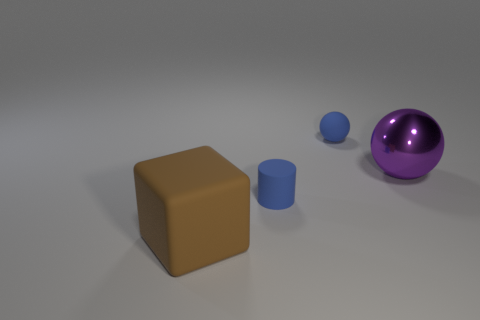Is the color of the tiny ball the same as the small thing that is in front of the metallic ball?
Make the answer very short. Yes. There is a blue matte thing that is behind the purple shiny thing; is it the same shape as the big purple thing?
Keep it short and to the point. Yes. How many large things are either cyan blocks or matte cylinders?
Provide a succinct answer. 0. Is the material of the blue cylinder the same as the small blue ball?
Provide a succinct answer. Yes. Are there any big rubber objects of the same color as the large metal thing?
Ensure brevity in your answer.  No. There is a brown cube that is the same material as the cylinder; what is its size?
Keep it short and to the point. Large. What shape is the object left of the tiny object that is in front of the big thing that is behind the brown rubber cube?
Your response must be concise. Cube. What is the size of the other object that is the same shape as the big purple thing?
Provide a succinct answer. Small. There is a object that is both in front of the small blue ball and to the right of the rubber cylinder; how big is it?
Provide a succinct answer. Large. The small thing that is the same color as the matte sphere is what shape?
Make the answer very short. Cylinder. 